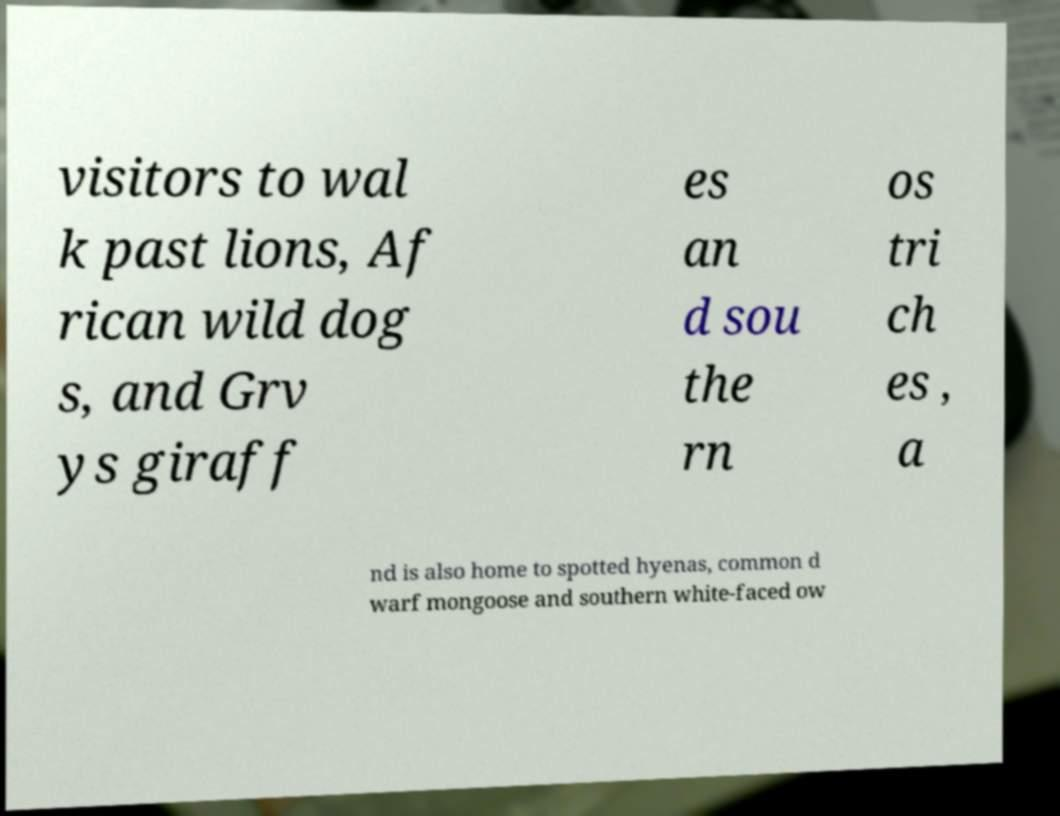There's text embedded in this image that I need extracted. Can you transcribe it verbatim? visitors to wal k past lions, Af rican wild dog s, and Grv ys giraff es an d sou the rn os tri ch es , a nd is also home to spotted hyenas, common d warf mongoose and southern white-faced ow 